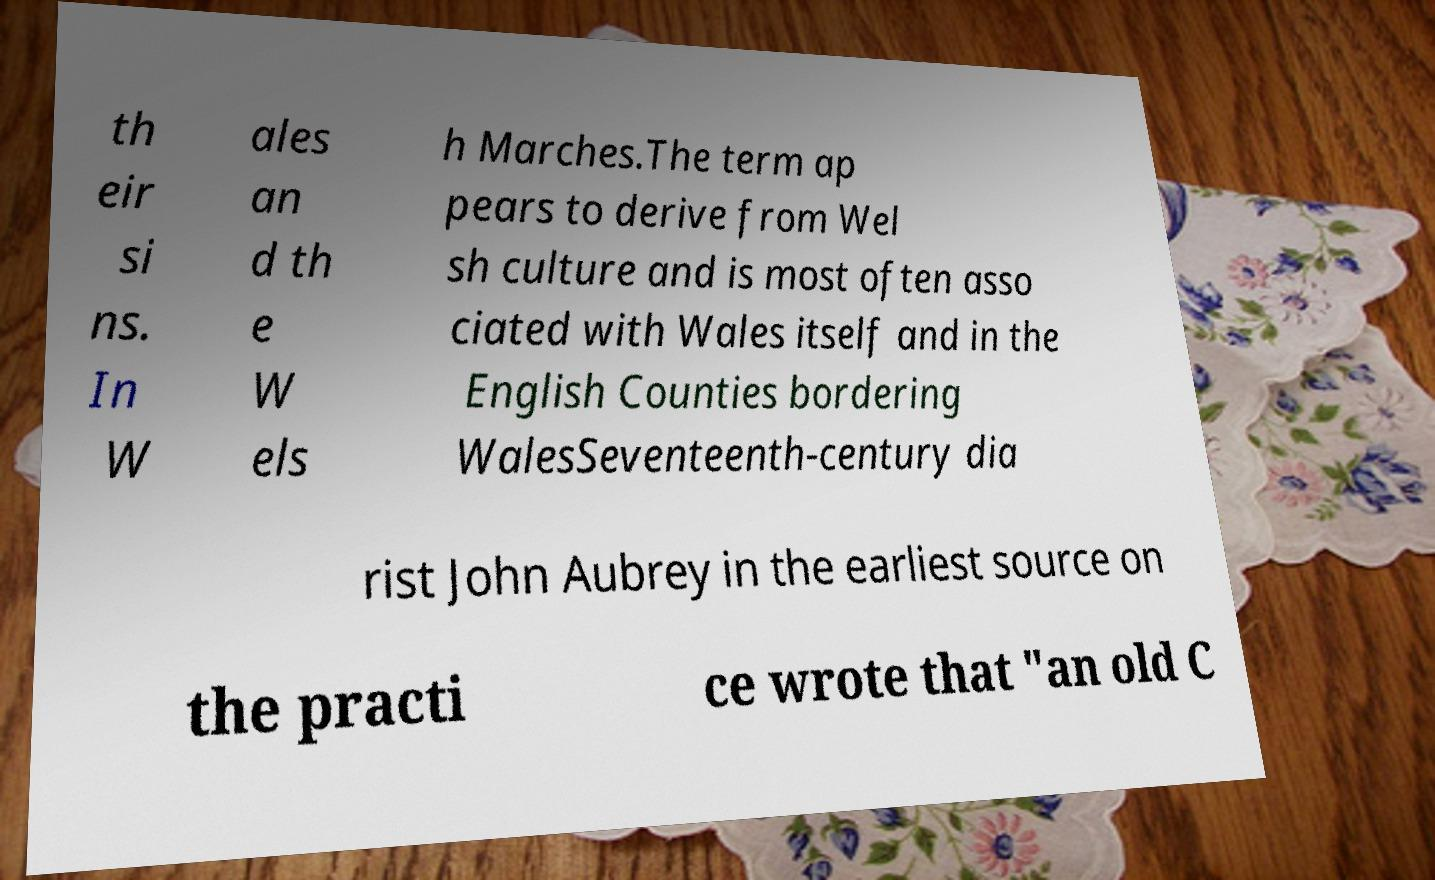Please identify and transcribe the text found in this image. th eir si ns. In W ales an d th e W els h Marches.The term ap pears to derive from Wel sh culture and is most often asso ciated with Wales itself and in the English Counties bordering WalesSeventeenth-century dia rist John Aubrey in the earliest source on the practi ce wrote that "an old C 